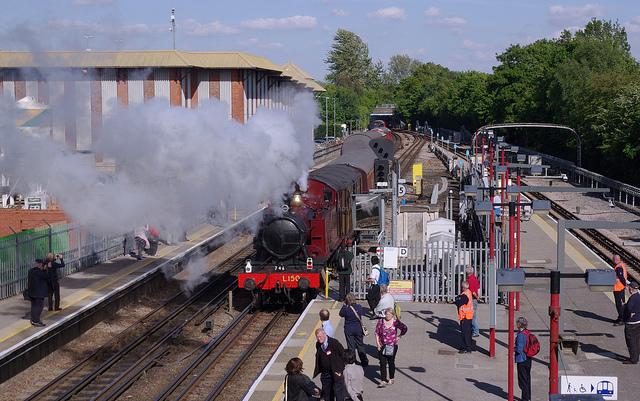How many buildings do you see?
Answer briefly. 1. Is this train a steam train?
Quick response, please. Yes. Is this a train station?
Write a very short answer. Yes. Where is the white and blue sign?
Keep it brief. Bottom right. 